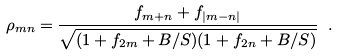Convert formula to latex. <formula><loc_0><loc_0><loc_500><loc_500>\rho _ { m n } = \frac { f _ { m + n } + f _ { | m - n | } } { \sqrt { ( 1 + f _ { 2 m } + B / S ) ( 1 + f _ { 2 n } + B / S ) } } \ .</formula> 